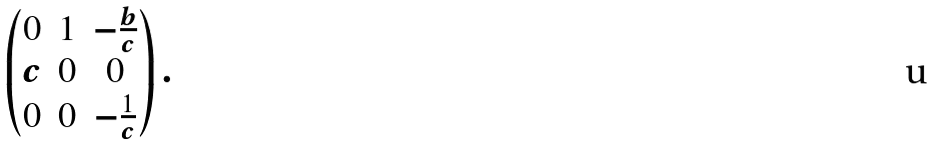<formula> <loc_0><loc_0><loc_500><loc_500>\begin{pmatrix} 0 & 1 & - \frac { b } { c } \\ c & 0 & 0 \\ 0 & 0 & - \frac { 1 } { c } \end{pmatrix} .</formula> 